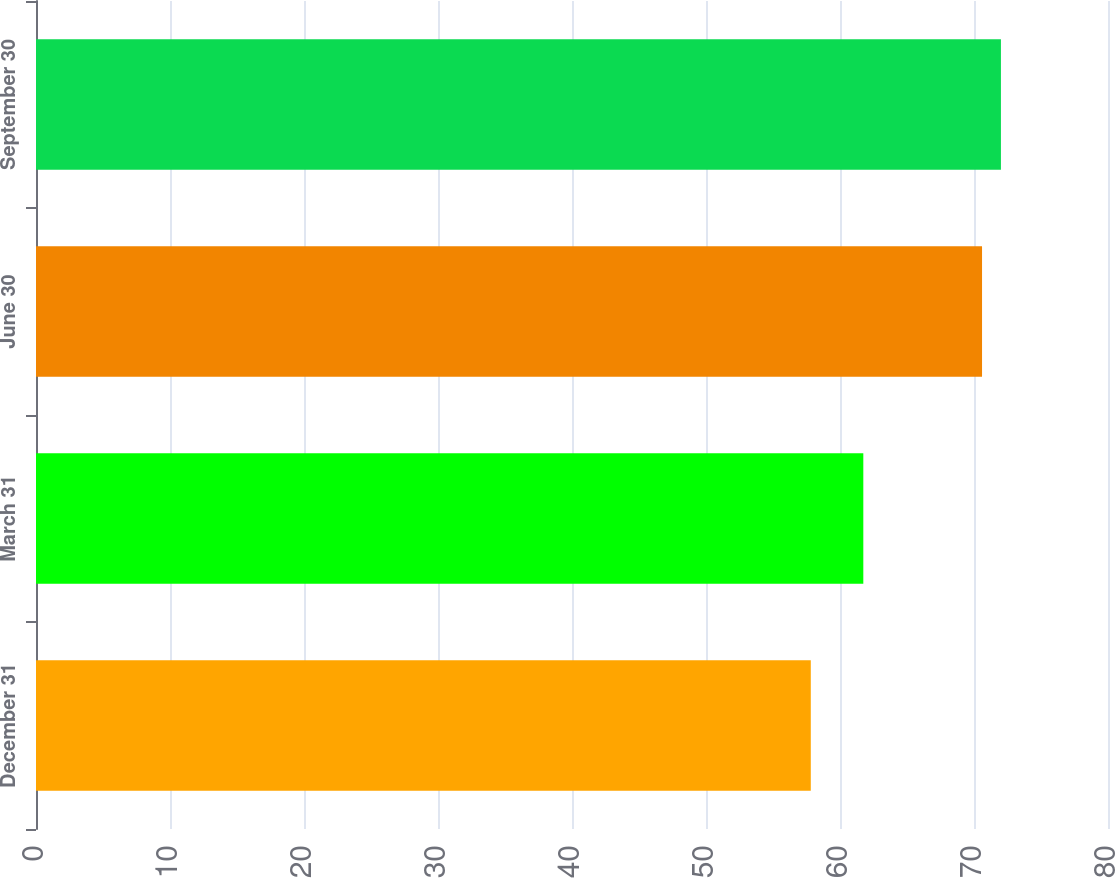<chart> <loc_0><loc_0><loc_500><loc_500><bar_chart><fcel>December 31<fcel>March 31<fcel>June 30<fcel>September 30<nl><fcel>57.82<fcel>61.74<fcel>70.6<fcel>72.01<nl></chart> 